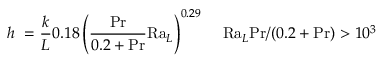Convert formula to latex. <formula><loc_0><loc_0><loc_500><loc_500>h \ = { \frac { k } { L } } 0 . 1 8 \left ( { \frac { P r } { 0 . 2 + P r } } R a _ { L } \right ) ^ { 0 . 2 9 } \, \quad R a _ { L } P r / ( 0 . 2 + P r ) > 1 0 ^ { 3 }</formula> 